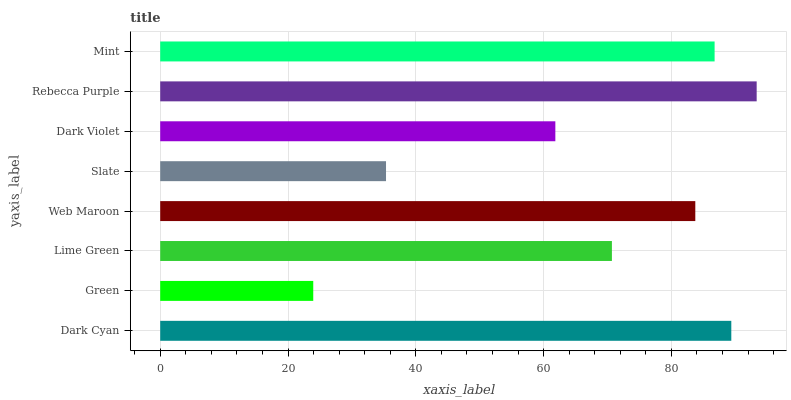Is Green the minimum?
Answer yes or no. Yes. Is Rebecca Purple the maximum?
Answer yes or no. Yes. Is Lime Green the minimum?
Answer yes or no. No. Is Lime Green the maximum?
Answer yes or no. No. Is Lime Green greater than Green?
Answer yes or no. Yes. Is Green less than Lime Green?
Answer yes or no. Yes. Is Green greater than Lime Green?
Answer yes or no. No. Is Lime Green less than Green?
Answer yes or no. No. Is Web Maroon the high median?
Answer yes or no. Yes. Is Lime Green the low median?
Answer yes or no. Yes. Is Rebecca Purple the high median?
Answer yes or no. No. Is Green the low median?
Answer yes or no. No. 